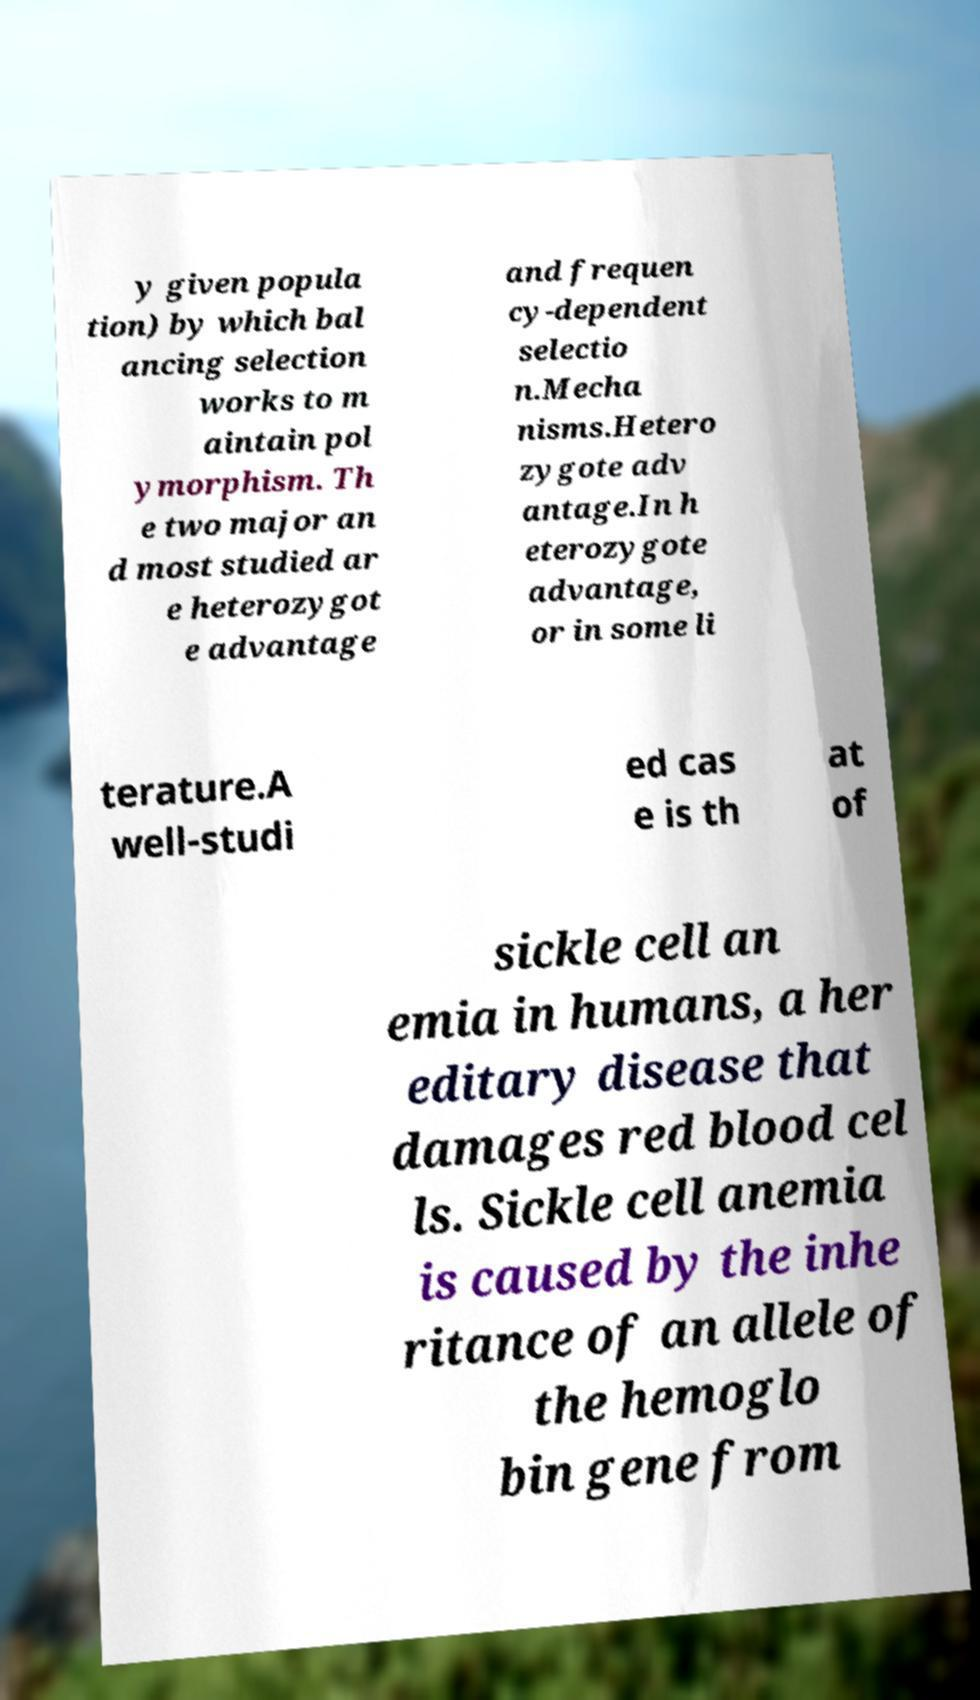What messages or text are displayed in this image? I need them in a readable, typed format. y given popula tion) by which bal ancing selection works to m aintain pol ymorphism. Th e two major an d most studied ar e heterozygot e advantage and frequen cy-dependent selectio n.Mecha nisms.Hetero zygote adv antage.In h eterozygote advantage, or in some li terature.A well-studi ed cas e is th at of sickle cell an emia in humans, a her editary disease that damages red blood cel ls. Sickle cell anemia is caused by the inhe ritance of an allele of the hemoglo bin gene from 